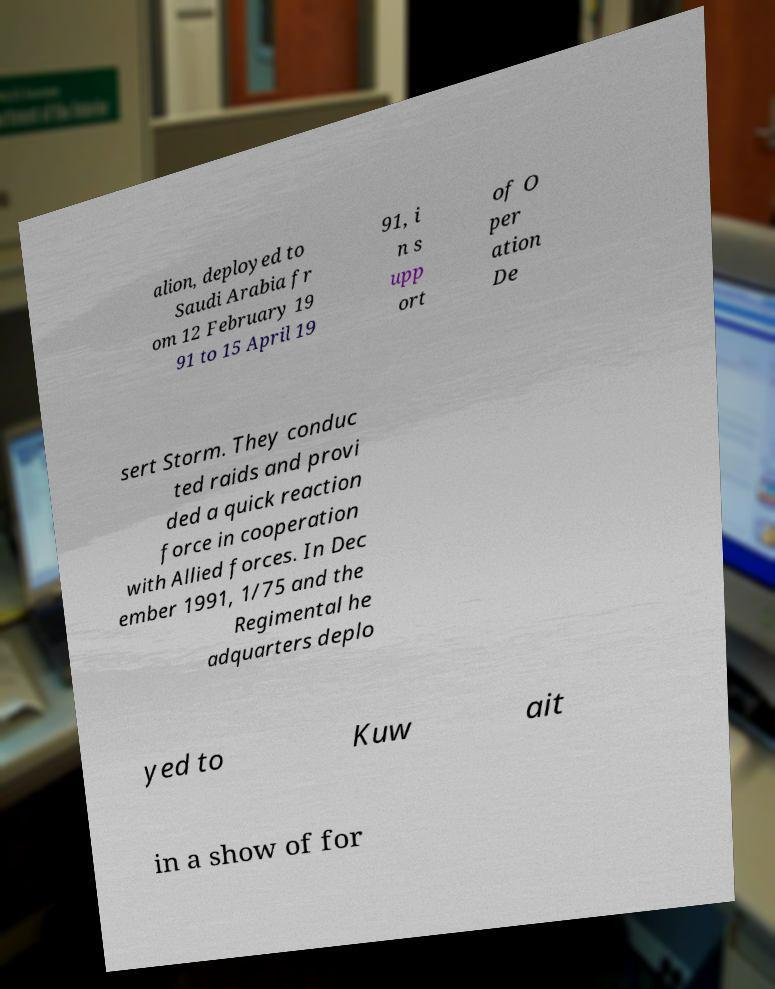Please identify and transcribe the text found in this image. alion, deployed to Saudi Arabia fr om 12 February 19 91 to 15 April 19 91, i n s upp ort of O per ation De sert Storm. They conduc ted raids and provi ded a quick reaction force in cooperation with Allied forces. In Dec ember 1991, 1/75 and the Regimental he adquarters deplo yed to Kuw ait in a show of for 